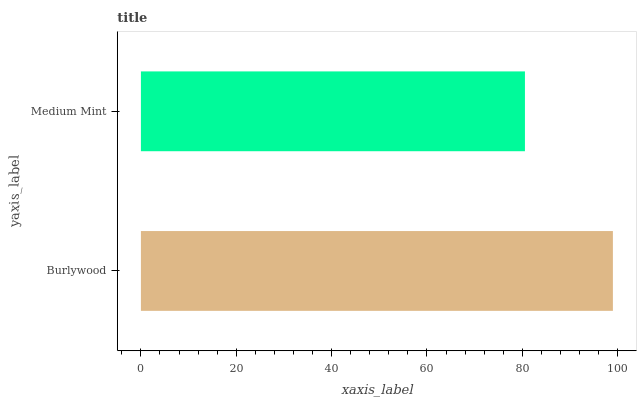Is Medium Mint the minimum?
Answer yes or no. Yes. Is Burlywood the maximum?
Answer yes or no. Yes. Is Medium Mint the maximum?
Answer yes or no. No. Is Burlywood greater than Medium Mint?
Answer yes or no. Yes. Is Medium Mint less than Burlywood?
Answer yes or no. Yes. Is Medium Mint greater than Burlywood?
Answer yes or no. No. Is Burlywood less than Medium Mint?
Answer yes or no. No. Is Burlywood the high median?
Answer yes or no. Yes. Is Medium Mint the low median?
Answer yes or no. Yes. Is Medium Mint the high median?
Answer yes or no. No. Is Burlywood the low median?
Answer yes or no. No. 